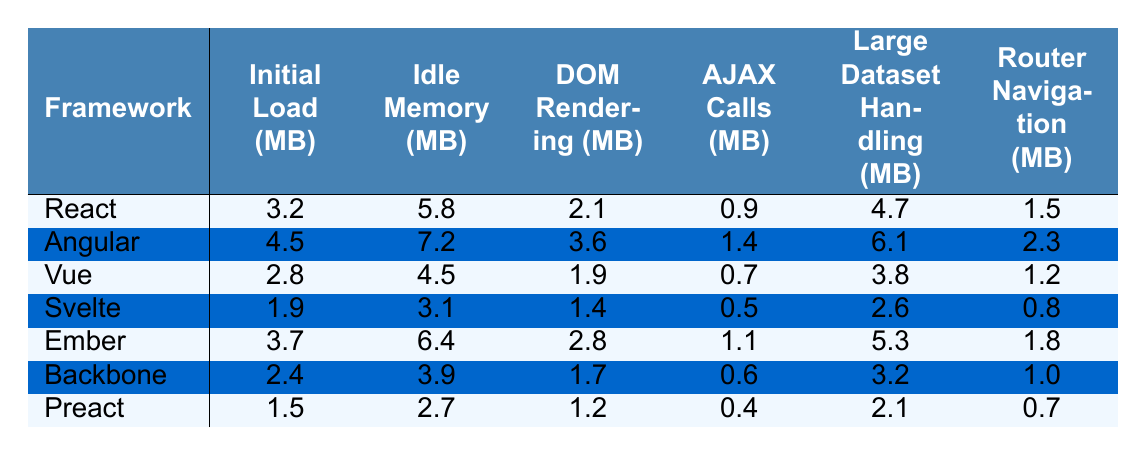What is the initial load memory for Angular? The table shows that the initial load memory for Angular is 4.5 MB.
Answer: 4.5 MB Which framework has the lowest idle memory usage? By looking at the idle memory values in the table, Preact has the lowest idle memory usage at 2.7 MB.
Answer: Preact What is the difference in DOM rendering memory between React and Vue? The DOM rendering memory for React is 2.1 MB and for Vue is 1.9 MB. The difference is 2.1 MB - 1.9 MB = 0.2 MB.
Answer: 0.2 MB Which framework has the highest memory usage for AJAX calls? From the table, Angular has the highest memory usage for AJAX calls at 1.4 MB.
Answer: Angular What is the average memory utilized for initial load across all frameworks? We sum the initial load values: (3.2 + 4.5 + 2.8 + 1.9 + 3.7 + 2.4 + 1.5) = 19.0 MB. There are 7 frameworks, so the average is 19.0 / 7 = 2.71 MB.
Answer: 2.71 MB Does Svelte have lower router navigation memory use than Ember? According to the table, Svelte uses 0.8 MB for router navigation while Ember uses 1.8 MB. Since 0.8 MB is less than 1.8 MB, the answer is yes.
Answer: Yes What is the total memory usage for large dataset handling among all frameworks? The values for large dataset handling are: (4.7 + 6.1 + 3.8 + 2.6 + 5.3 + 3.2 + 2.1) = 28.8 MB.
Answer: 28.8 MB Which framework exhibits the highest idle memory usage? The table indicates that Angular has the highest idle memory usage at 7.2 MB.
Answer: Angular What is the median value for AJAX calls memory usage across the frameworks? The AJAX memory values are: [0.9, 1.4, 0.7, 0.5, 1.1, 0.6, 0.4]. When ordered, the middle value (the 4th value) is 0.7 MB, since there are an odd number of values.
Answer: 0.7 MB If we ranked the frameworks by initial load memory, which framework would be ranked 2nd? The initial load values in ascending order are: 1.5 MB (Preact), 1.9 MB (Svelte), 2.4 MB (Backbone), 2.8 MB (Vue), 3.2 MB (React), 3.7 MB (Ember), and 4.5 MB (Angular). Thus, Svelte would be ranked 2nd.
Answer: Svelte 